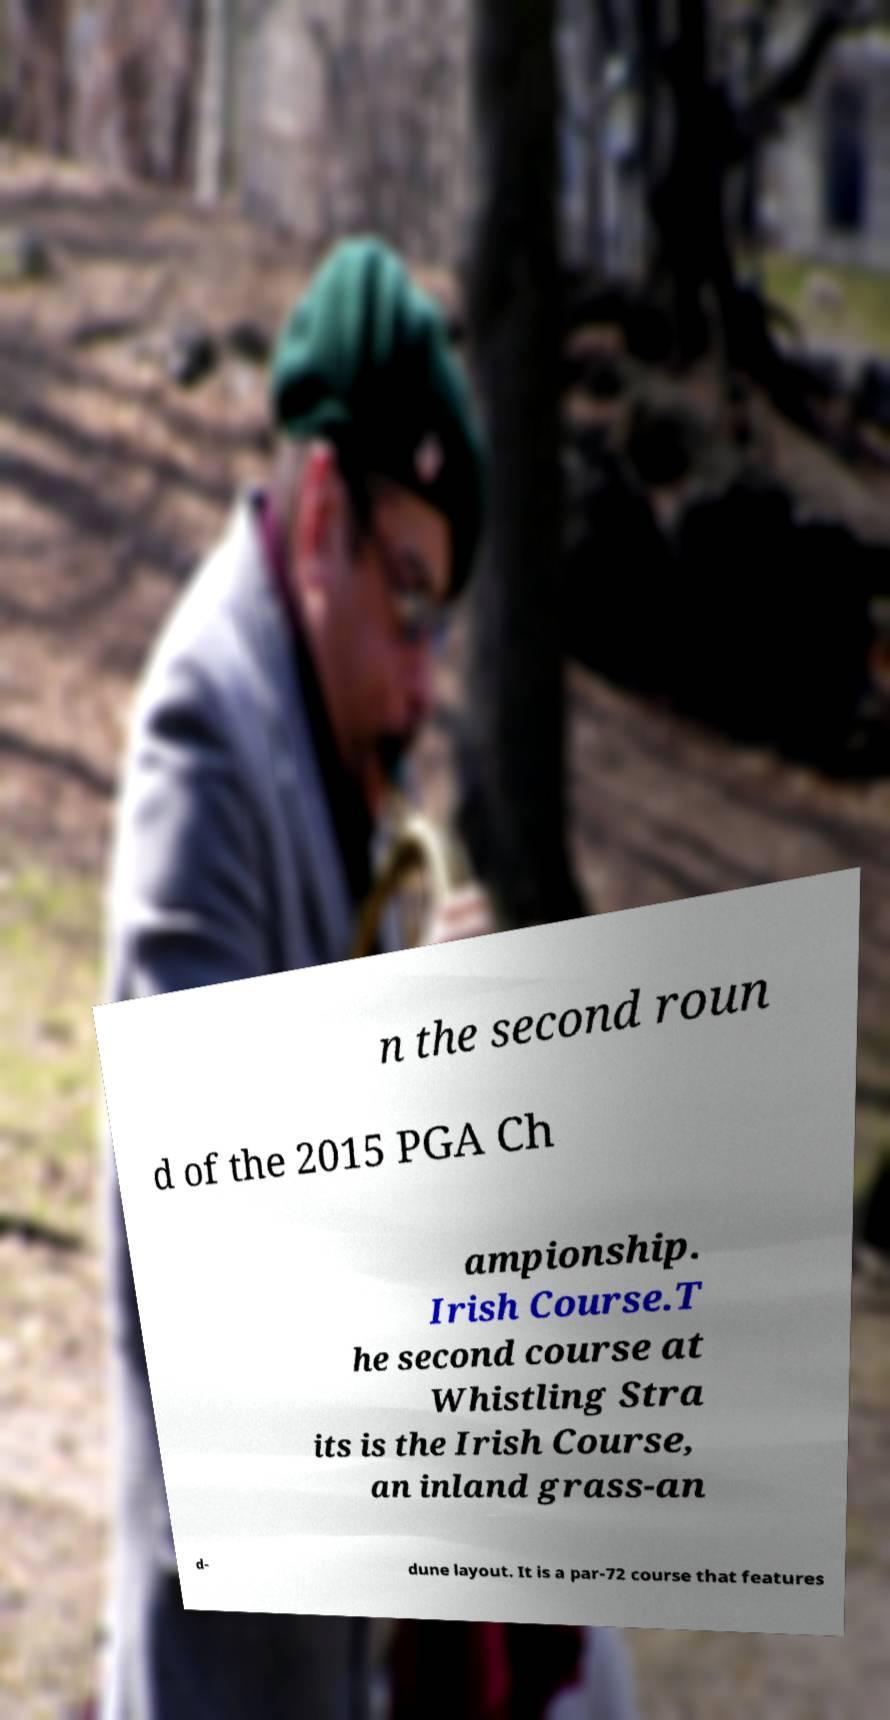For documentation purposes, I need the text within this image transcribed. Could you provide that? n the second roun d of the 2015 PGA Ch ampionship. Irish Course.T he second course at Whistling Stra its is the Irish Course, an inland grass-an d- dune layout. It is a par-72 course that features 